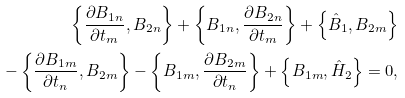<formula> <loc_0><loc_0><loc_500><loc_500>\left \{ \frac { \partial B _ { 1 n } } { \partial t _ { m } } , B _ { 2 n } \right \} + \left \{ B _ { 1 n } , \frac { \partial B _ { 2 n } } { \partial t _ { m } } \right \} + \left \{ { \hat { B } _ { 1 } } , B _ { 2 m } \right \} \\ - \left \{ \frac { \partial B _ { 1 m } } { \partial t _ { n } } , B _ { 2 m } \right \} - \left \{ B _ { 1 m } , \frac { \partial B _ { 2 m } } { \partial t _ { n } } \right \} + \left \{ B _ { 1 m } , { \hat { H } } _ { 2 } \right \} = 0 ,</formula> 